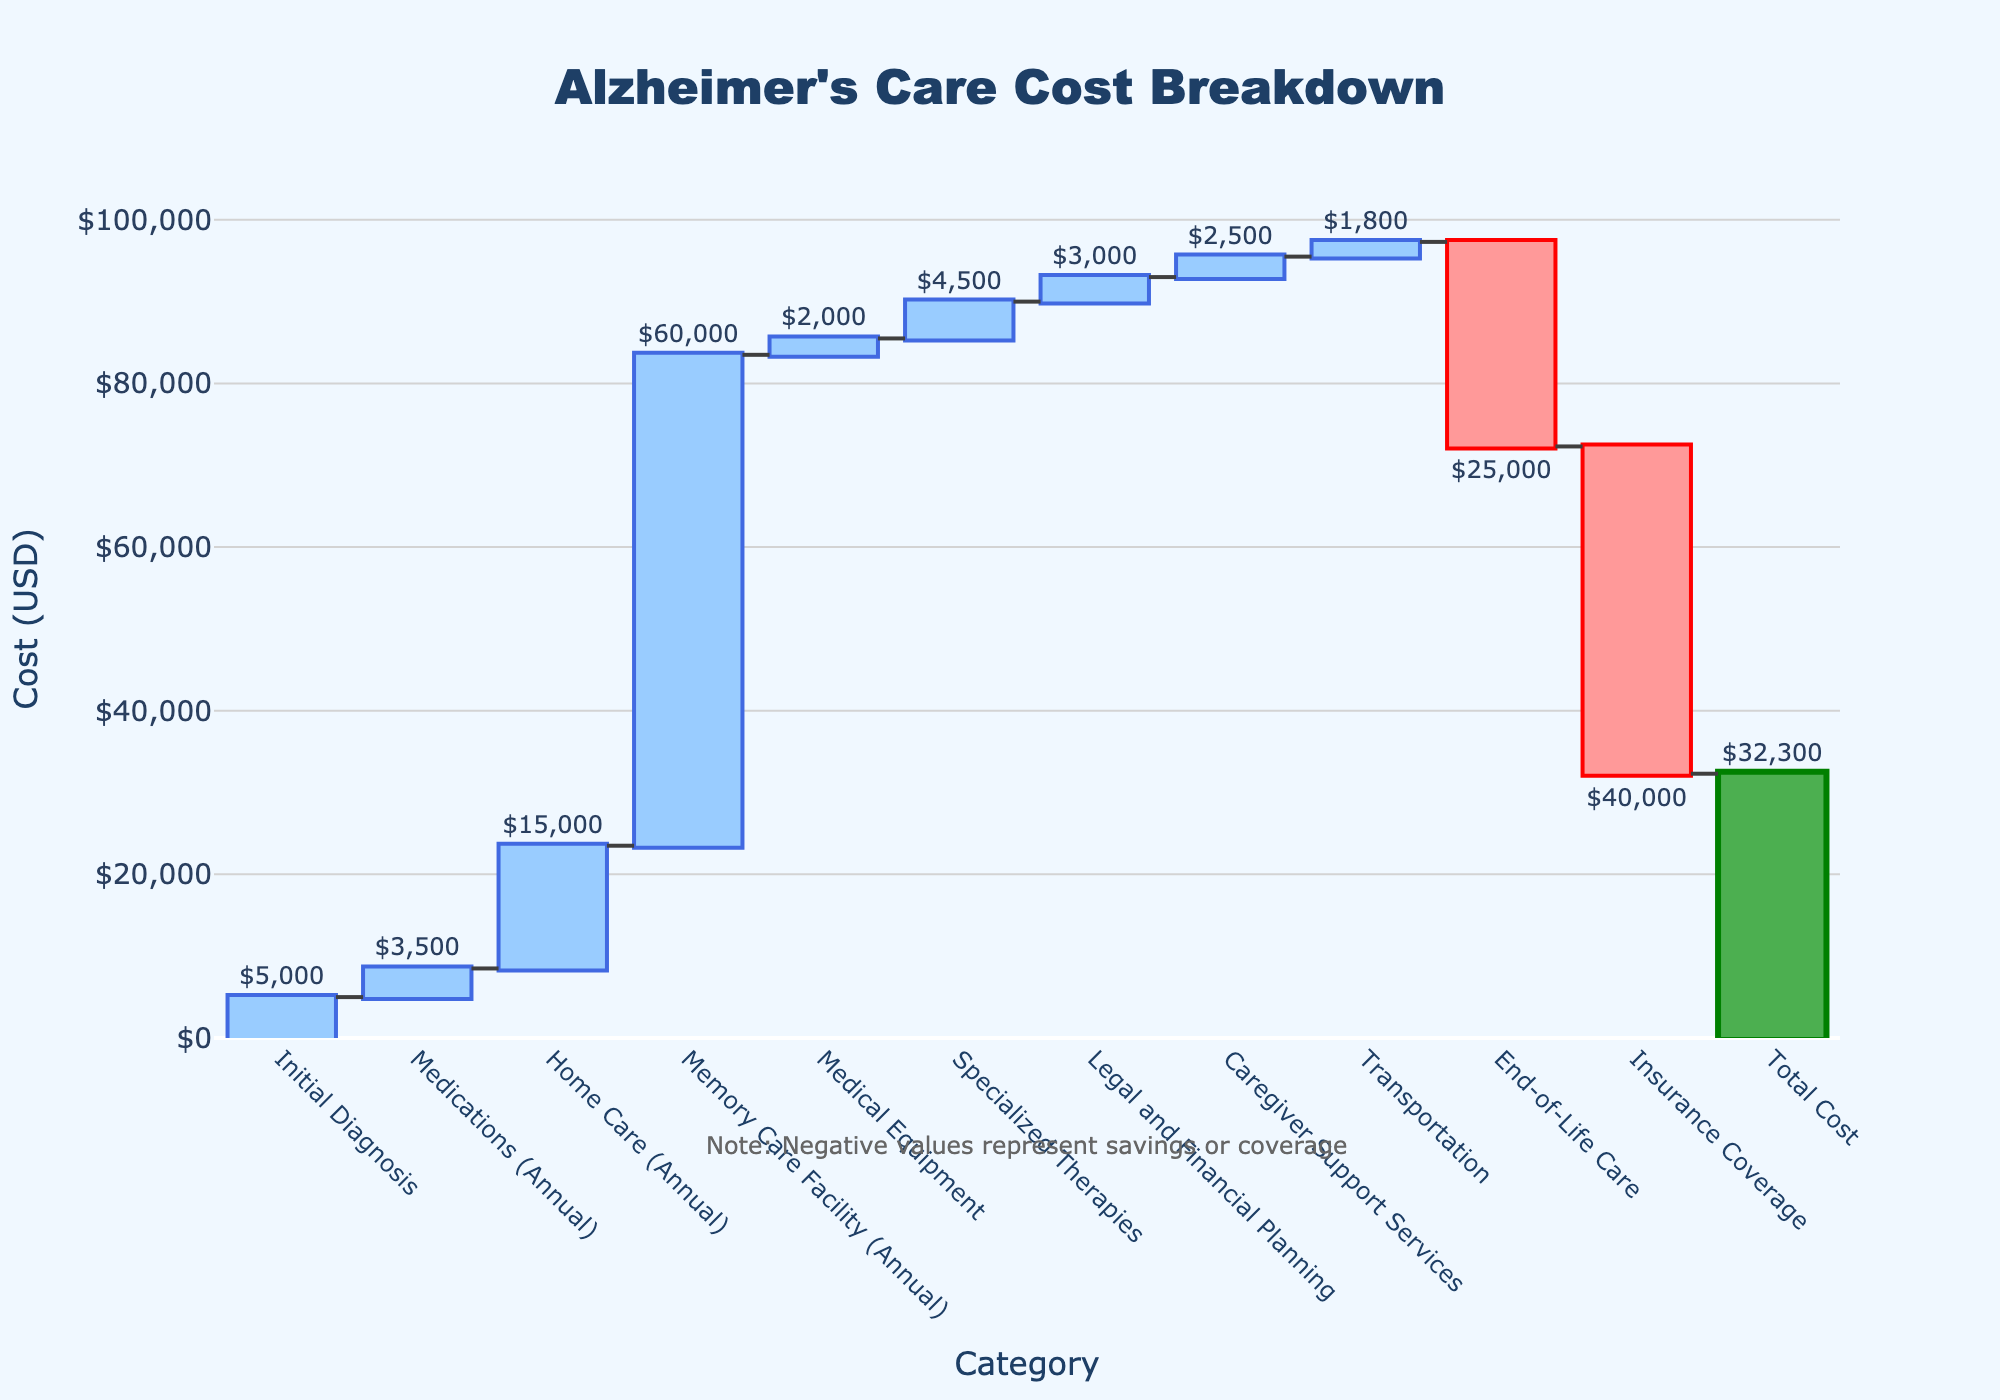What's the title of the figure? The title of the chart is typically displayed prominently at the top of the figure.
Answer: Alzheimer's Care Cost Breakdown What is the total cost of Alzheimer's care according to the chart? The total cost is usually represented by the final bar in the Waterfall Chart, marked as "Total Cost". The figure for "Total Cost" is shown as a text label on the bar.
Answer: $32,300 Which category contributes the most to the cost? To identify the highest contributing category, look for the tallest single bar that represents an increase in cost. Here, "Memory Care Facility" has the highest bar.
Answer: Memory Care Facility Which costs are offset by savings or coverage? In a Waterfall Chart, savings or coverage are often represented by bars that decrease (usually shown in a different color). Here, "End-of-Life Care" and "Insurance Coverage" have negative values.
Answer: End-of-Life Care and Insurance Coverage What is the combined annual cost of Medications, Home Care, and Memory Care Facility? Add the values of the bars for "Medications (Annual)", "Home Care (Annual)", and "Memory Care Facility (Annual)". The combined cost is $3,500 + $15,000 + $60,000.
Answer: $78,500 How much does "Home Care (Annual)" cost compared to "Specialized Therapies"? Compare the heights of the two bars for "Home Care (Annual)" and "Specialized Therapies". Home Care is $15,000 and Specialized Therapies is $4,500. Calculation: $15,000 - $4,500.
Answer: $10,500 more What is the total cost of initial diagnosis, medical equipment, and legal and financial planning? Sum up the values for "Initial Diagnosis", "Medical Equipment", and "Legal and Financial Planning". Calculation: $5,000 + $2,000 + $3,000.
Answer: $10,000 How much does caregiver support services cost? Find the "Caregiver Support Services" bar and read the value directly from it. In this case, the value is shown as a text label.
Answer: $2,500 Which category contributes the least to the cost excluding the negative values? Identify the shortest bar representing a positive value. Here, "Transportation" has the smallest height among positive values.
Answer: Transportation What is the total cost after adding all expenses and subtracting the savings/coverage? Start with the initial values, add all positive values, and subtract negative values. Verification: $5,000 + $3,500 + $15,000 + $60,000 + $2,000 + $4,500 + $3,000 + $2,500 + $1,800 - $25,000 - $40,000. Calculation: $32,300.
Answer: $32,300 